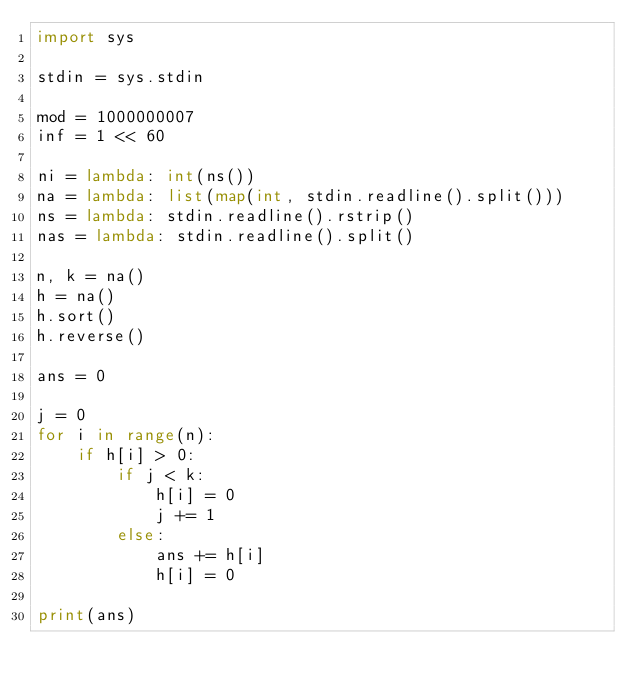<code> <loc_0><loc_0><loc_500><loc_500><_Python_>import sys

stdin = sys.stdin

mod = 1000000007
inf = 1 << 60

ni = lambda: int(ns())
na = lambda: list(map(int, stdin.readline().split()))
ns = lambda: stdin.readline().rstrip()
nas = lambda: stdin.readline().split()

n, k = na()
h = na()
h.sort()
h.reverse()

ans = 0

j = 0
for i in range(n):
    if h[i] > 0:
        if j < k:
            h[i] = 0
            j += 1
        else:
            ans += h[i]
            h[i] = 0

print(ans)</code> 